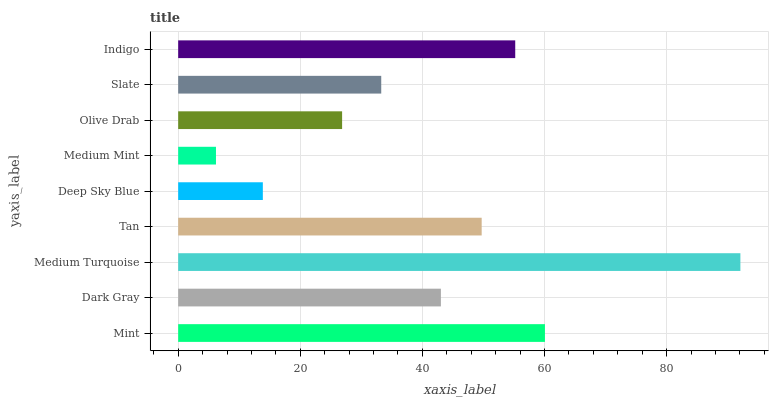Is Medium Mint the minimum?
Answer yes or no. Yes. Is Medium Turquoise the maximum?
Answer yes or no. Yes. Is Dark Gray the minimum?
Answer yes or no. No. Is Dark Gray the maximum?
Answer yes or no. No. Is Mint greater than Dark Gray?
Answer yes or no. Yes. Is Dark Gray less than Mint?
Answer yes or no. Yes. Is Dark Gray greater than Mint?
Answer yes or no. No. Is Mint less than Dark Gray?
Answer yes or no. No. Is Dark Gray the high median?
Answer yes or no. Yes. Is Dark Gray the low median?
Answer yes or no. Yes. Is Mint the high median?
Answer yes or no. No. Is Tan the low median?
Answer yes or no. No. 